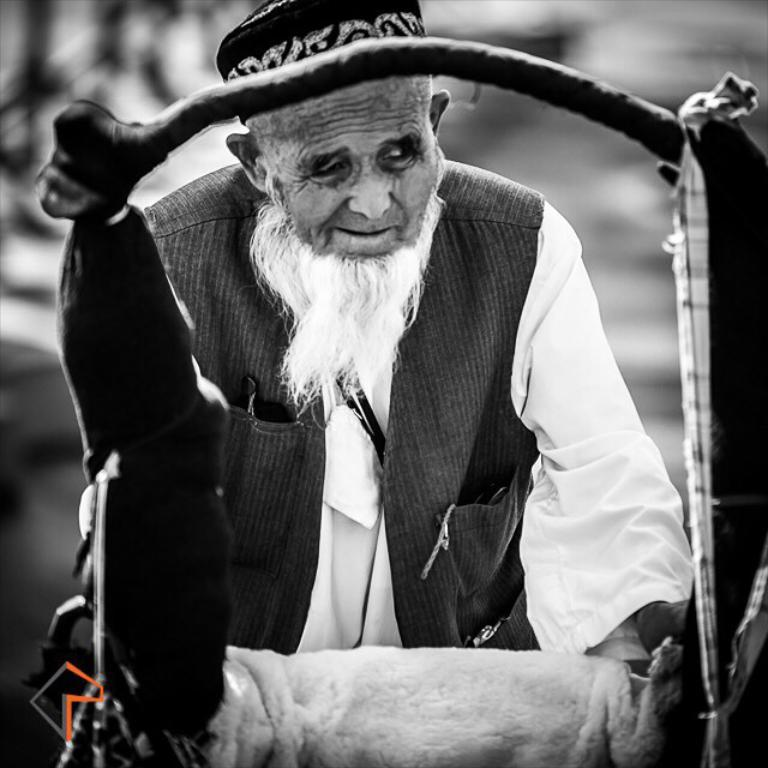What is the color scheme of the image? The image is black and white. Can you describe the person in the image? The person is wearing a cap. What object can be seen in the image besides the person? There is a stand, a cloth, and a logo in the image. Can you see any letters sparking in the image? There are no letters or sparks present in the image. Are there any flies visible in the image? There are no flies visible in the image. 